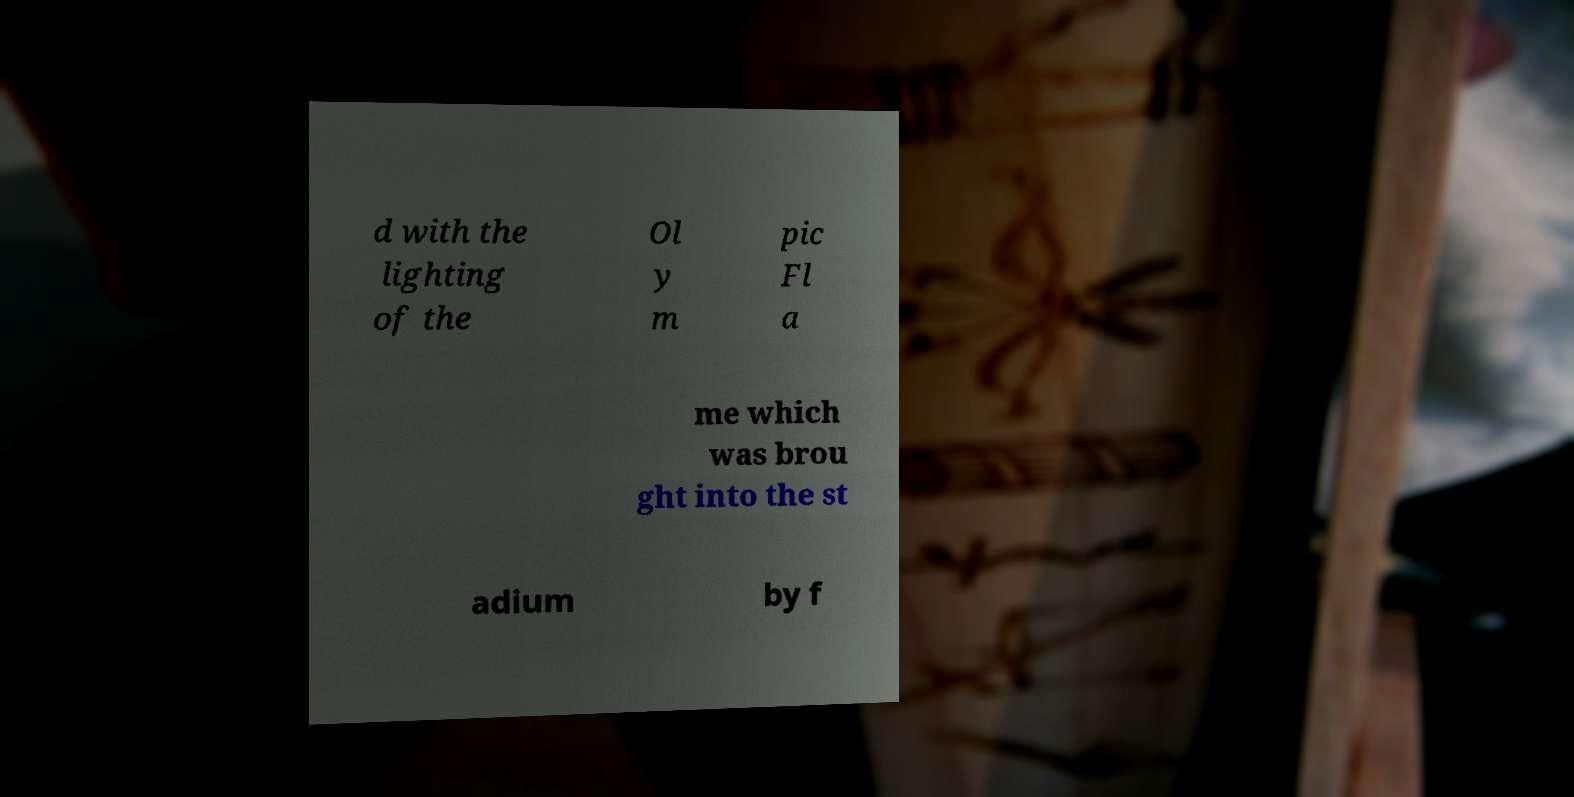Can you accurately transcribe the text from the provided image for me? d with the lighting of the Ol y m pic Fl a me which was brou ght into the st adium by f 